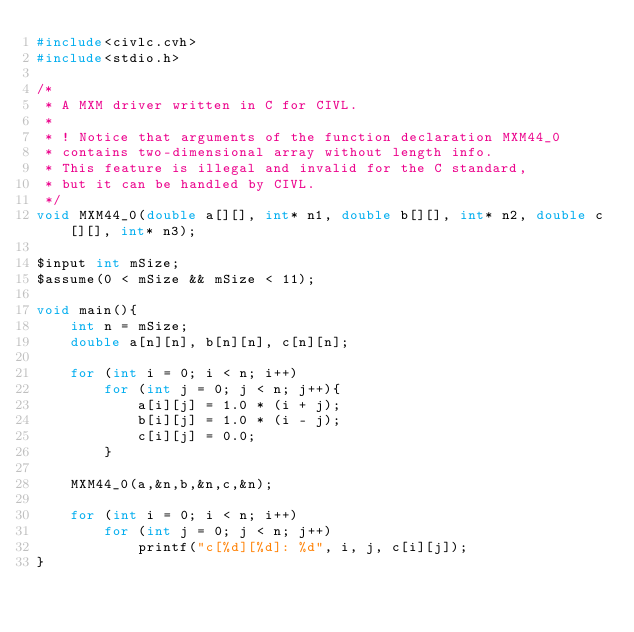<code> <loc_0><loc_0><loc_500><loc_500><_C_>#include<civlc.cvh>
#include<stdio.h>

/* 
 * A MXM driver written in C for CIVL.
 *
 * ! Notice that arguments of the function declaration MXM44_0
 * contains two-dimensional array without length info. 
 * This feature is illegal and invalid for the C standard, 
 * but it can be handled by CIVL.
 */
void MXM44_0(double a[][], int* n1, double b[][], int* n2, double c[][], int* n3);

$input int mSize;
$assume(0 < mSize && mSize < 11);

void main(){
    int n = mSize;
    double a[n][n], b[n][n], c[n][n];
    
    for (int i = 0; i < n; i++)
        for (int j = 0; j < n; j++){
            a[i][j] = 1.0 * (i + j);
            b[i][j] = 1.0 * (i - j);
            c[i][j] = 0.0;
        }
    
    MXM44_0(a,&n,b,&n,c,&n);
    
    for (int i = 0; i < n; i++)
        for (int j = 0; j < n; j++)
            printf("c[%d][%d]: %d", i, j, c[i][j]);
}

</code> 